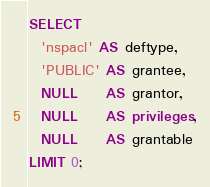<code> <loc_0><loc_0><loc_500><loc_500><_SQL_>SELECT
  'nspacl' AS deftype,
  'PUBLIC' AS grantee,
  NULL     AS grantor,
  NULL     AS privileges,
  NULL     AS grantable
LIMIT 0;
</code> 